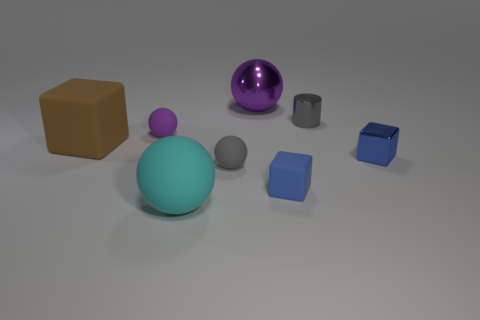Add 1 tiny yellow cylinders. How many objects exist? 9 Subtract all cubes. How many objects are left? 5 Add 1 rubber cubes. How many rubber cubes are left? 3 Add 5 small blue shiny cylinders. How many small blue shiny cylinders exist? 5 Subtract 1 cyan balls. How many objects are left? 7 Subtract all brown matte spheres. Subtract all large cyan objects. How many objects are left? 7 